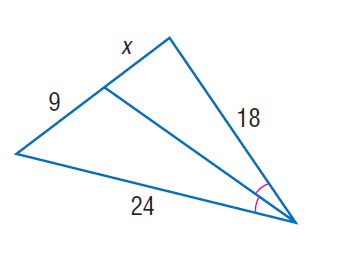Question: Find x.
Choices:
A. 6
B. 6.25
C. 6.5
D. 6.75
Answer with the letter. Answer: D 